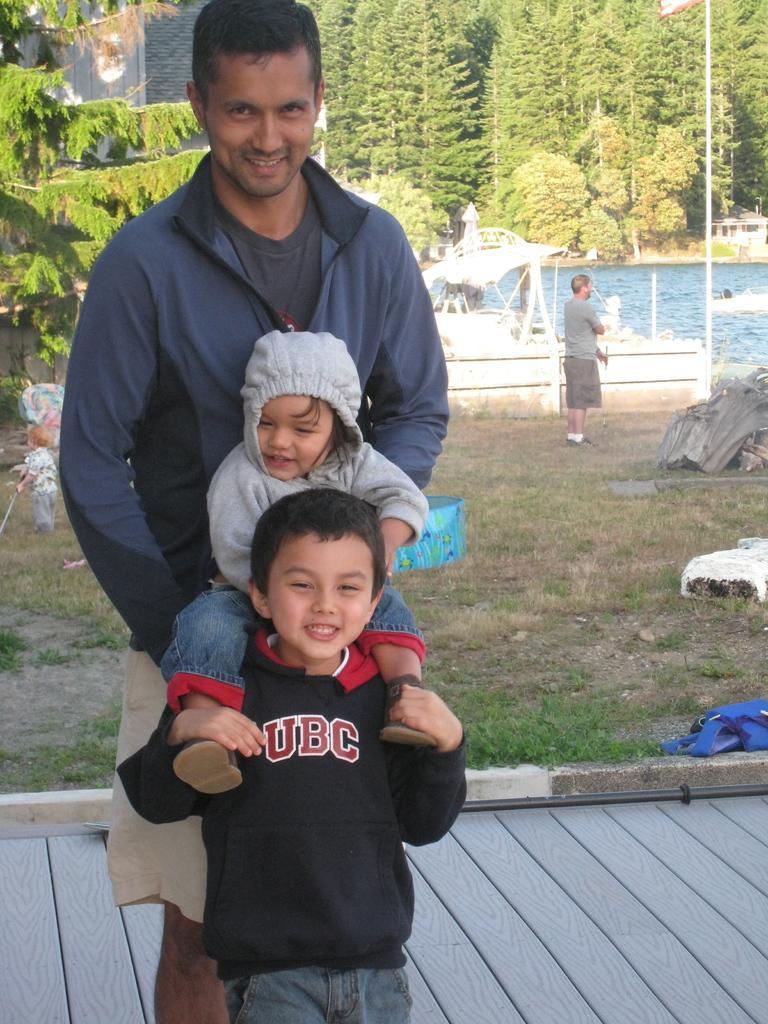Could you give a brief overview of what you see in this image? In this image, we can see a kid holding a baby and in the background, there are people and there is an other kid holding a stick and we can see trees, a shed, a wall, some lights, boats on the water and there are poles, a bag, trolley and some other objects on the ground. 